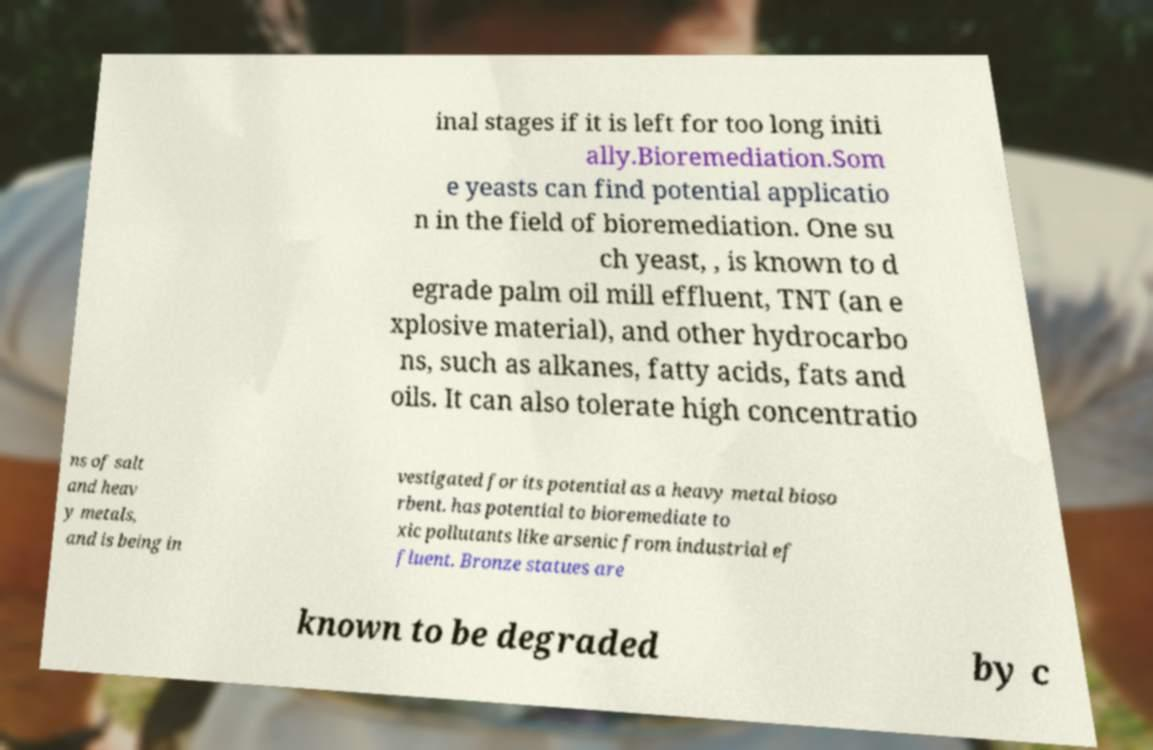There's text embedded in this image that I need extracted. Can you transcribe it verbatim? inal stages if it is left for too long initi ally.Bioremediation.Som e yeasts can find potential applicatio n in the field of bioremediation. One su ch yeast, , is known to d egrade palm oil mill effluent, TNT (an e xplosive material), and other hydrocarbo ns, such as alkanes, fatty acids, fats and oils. It can also tolerate high concentratio ns of salt and heav y metals, and is being in vestigated for its potential as a heavy metal bioso rbent. has potential to bioremediate to xic pollutants like arsenic from industrial ef fluent. Bronze statues are known to be degraded by c 